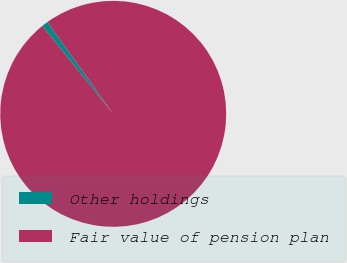Convert chart. <chart><loc_0><loc_0><loc_500><loc_500><pie_chart><fcel>Other holdings<fcel>Fair value of pension plan<nl><fcel>0.89%<fcel>99.11%<nl></chart> 